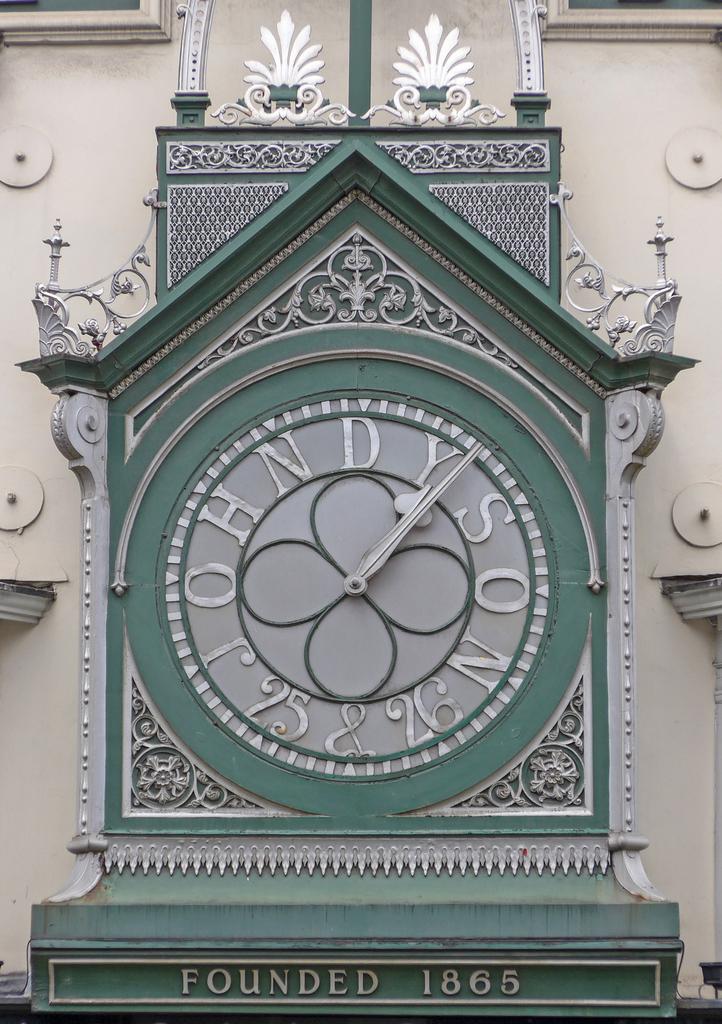What time is on the clock ?
Keep it short and to the point. 1:06. 